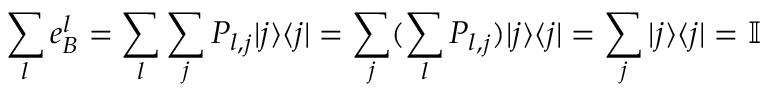<formula> <loc_0><loc_0><loc_500><loc_500>\sum _ { l } e _ { B } ^ { l } = \sum _ { l } \sum _ { j } P _ { l , j } | j \rangle \langle j | = \sum _ { j } ( \sum _ { l } P _ { l , j } ) | j \rangle \langle j | = \sum _ { j } | j \rangle \langle j | = \mathbb { I }</formula> 